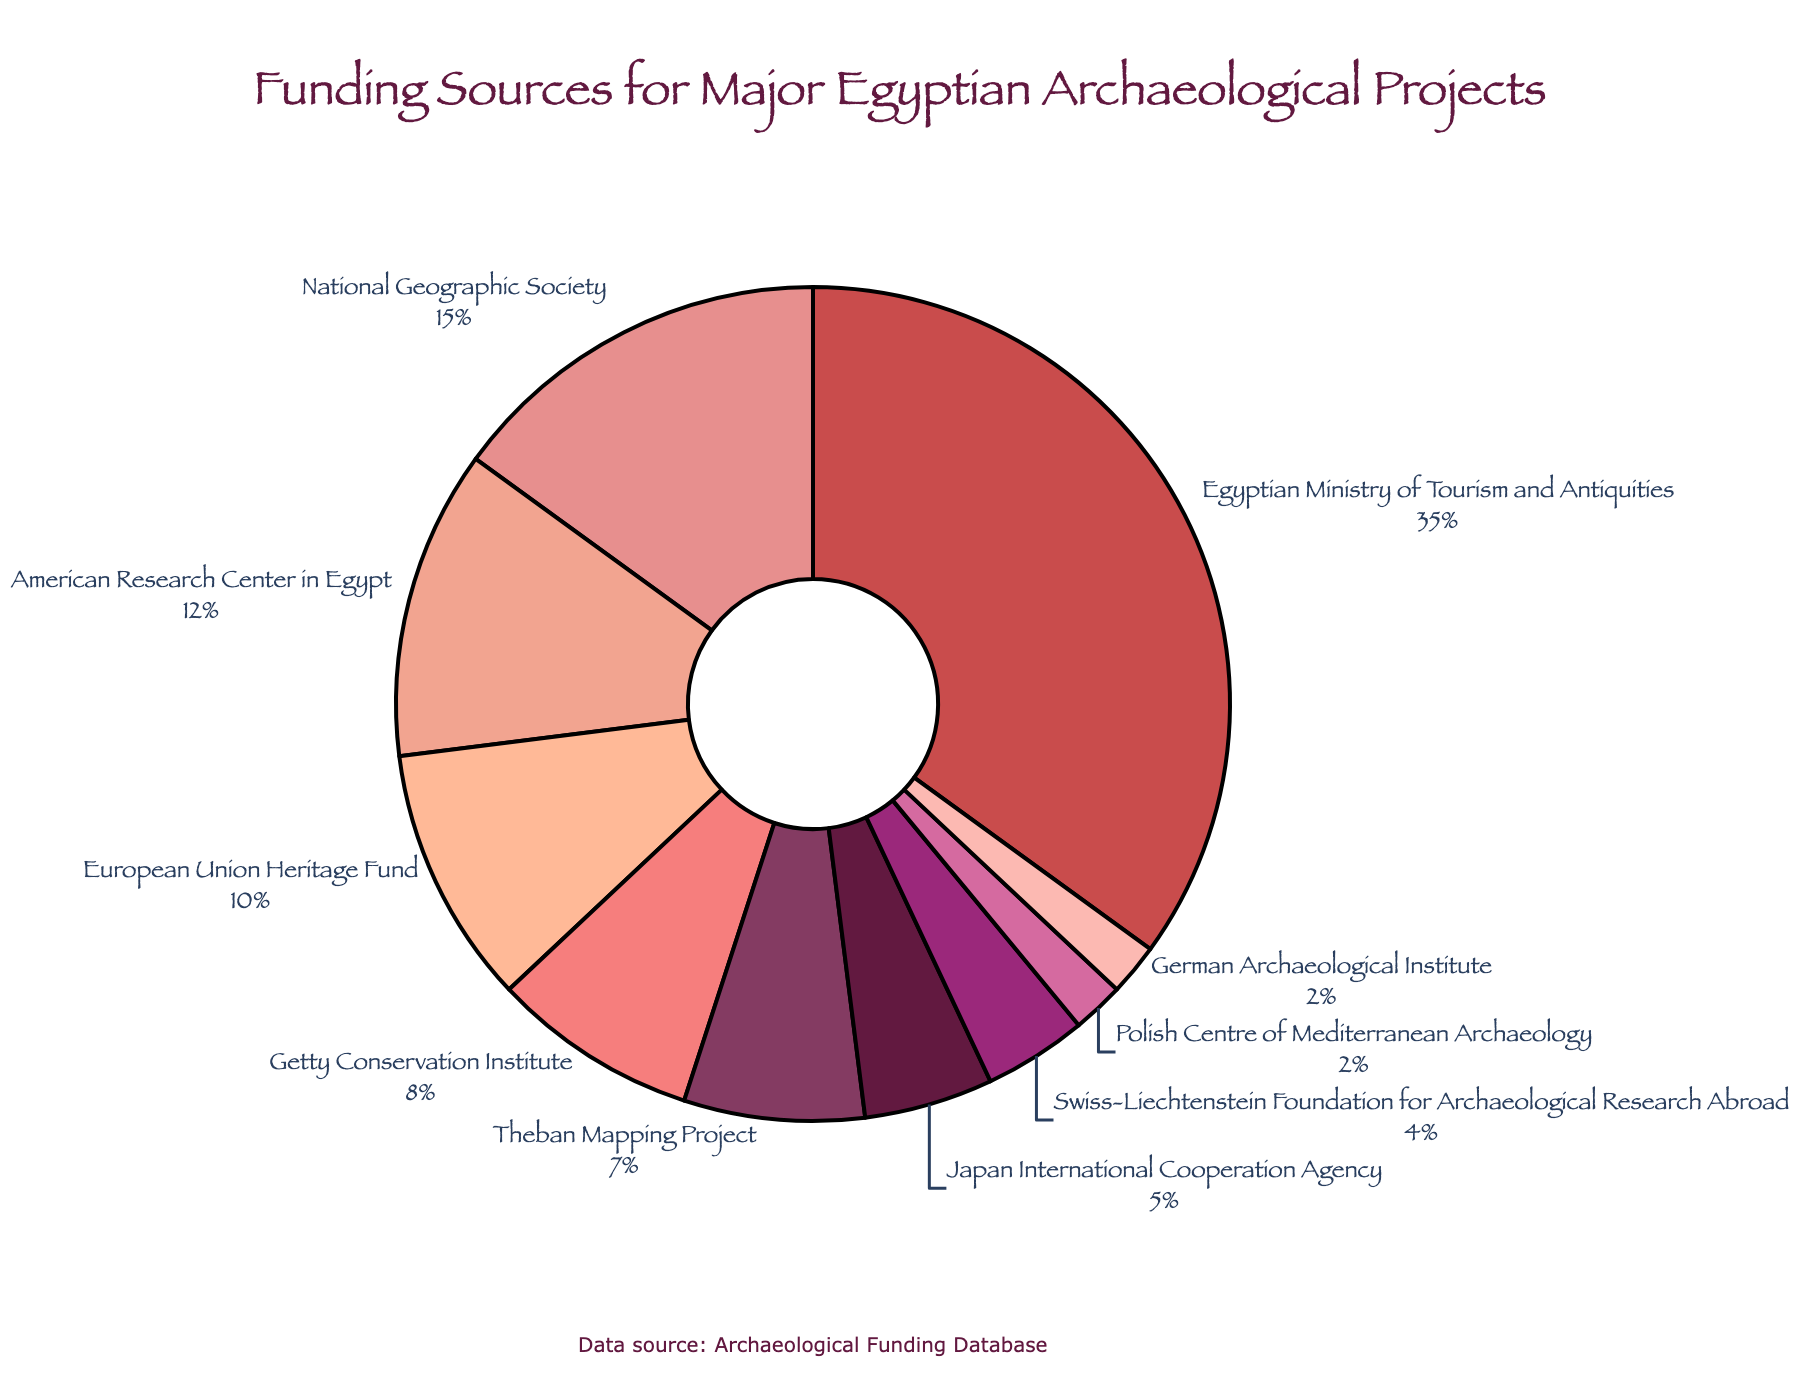What's the funding source with the highest percentage? Identify the segment in the pie chart that covers the largest area. The label shows "Egyptian Ministry of Tourism and Antiquities" with 35%.
Answer: Egyptian Ministry of Tourism and Antiquities Which organization contributes more, the Getty Conservation Institute or the Theban Mapping Project? Compare the percentage labels for both segments. The Getty Conservation Institute has 8% and the Theban Mapping Project has 7%, so the former contributes more.
Answer: Getty Conservation Institute What is the combined percentage of funds contributed by the National Geographic Society and the European Union Heritage Fund? Look for both segments labeled "National Geographic Society" (15%) and "European Union Heritage Fund" (10%), then add the percentages: 15% + 10% = 25%.
Answer: 25% Which funding sources have the same percentage of contribution? Look for segments with equal percentages and see that "Polish Centre of Mediterranean Archaeology" and "German Archaeological Institute" each have 2%.
Answer: Polish Centre of Mediterranean Archaeology, German Archaeological Institute What is the difference in funding percentage between the Egyptian Ministry of Tourism and Antiquities and the American Research Center in Egypt? Find both segments with their percentages: Egyptian Ministry of Tourism and Antiquities (35%) and American Research Center in Egypt (12%). Subtract: 35% - 12% = 23%.
Answer: 23% What is the second largest source of funding? Identify the second largest segment after the Egyptian Ministry of Tourism and Antiquities. The National Geographic Society at 15% is the second largest.
Answer: National Geographic Society How many sources contribute more than or equal to 10% individually? Identify all segments with percentages ≥ 10%: "Egyptian Ministry of Tourism and Antiquities" (35%), "National Geographic Society" (15%), "American Research Center in Egypt" (12%), "European Union Heritage Fund" (10%). Count these to find 4 sources.
Answer: 4 Which segment is visually positioned directly opposite to the National Geographic Society in the pie chart? Observe the chart layout to see that "Japan International Cooperation Agency" at 5% is opposite to "National Geographic Society".
Answer: Japan International Cooperation Agency What proportion of total funding comes from organizations with at least 5% contributions each? Sum the percentages of all segments with 5% or more: (35% + 15% + 12% + 10% + 8% + 7% + 5%) = 92%.
Answer: 92% Are there any funding sources that contribute only once in the pie chart? Check if each label appears only once in the pie chart. All segments are uniquely identified by their respective labels.
Answer: Yes 